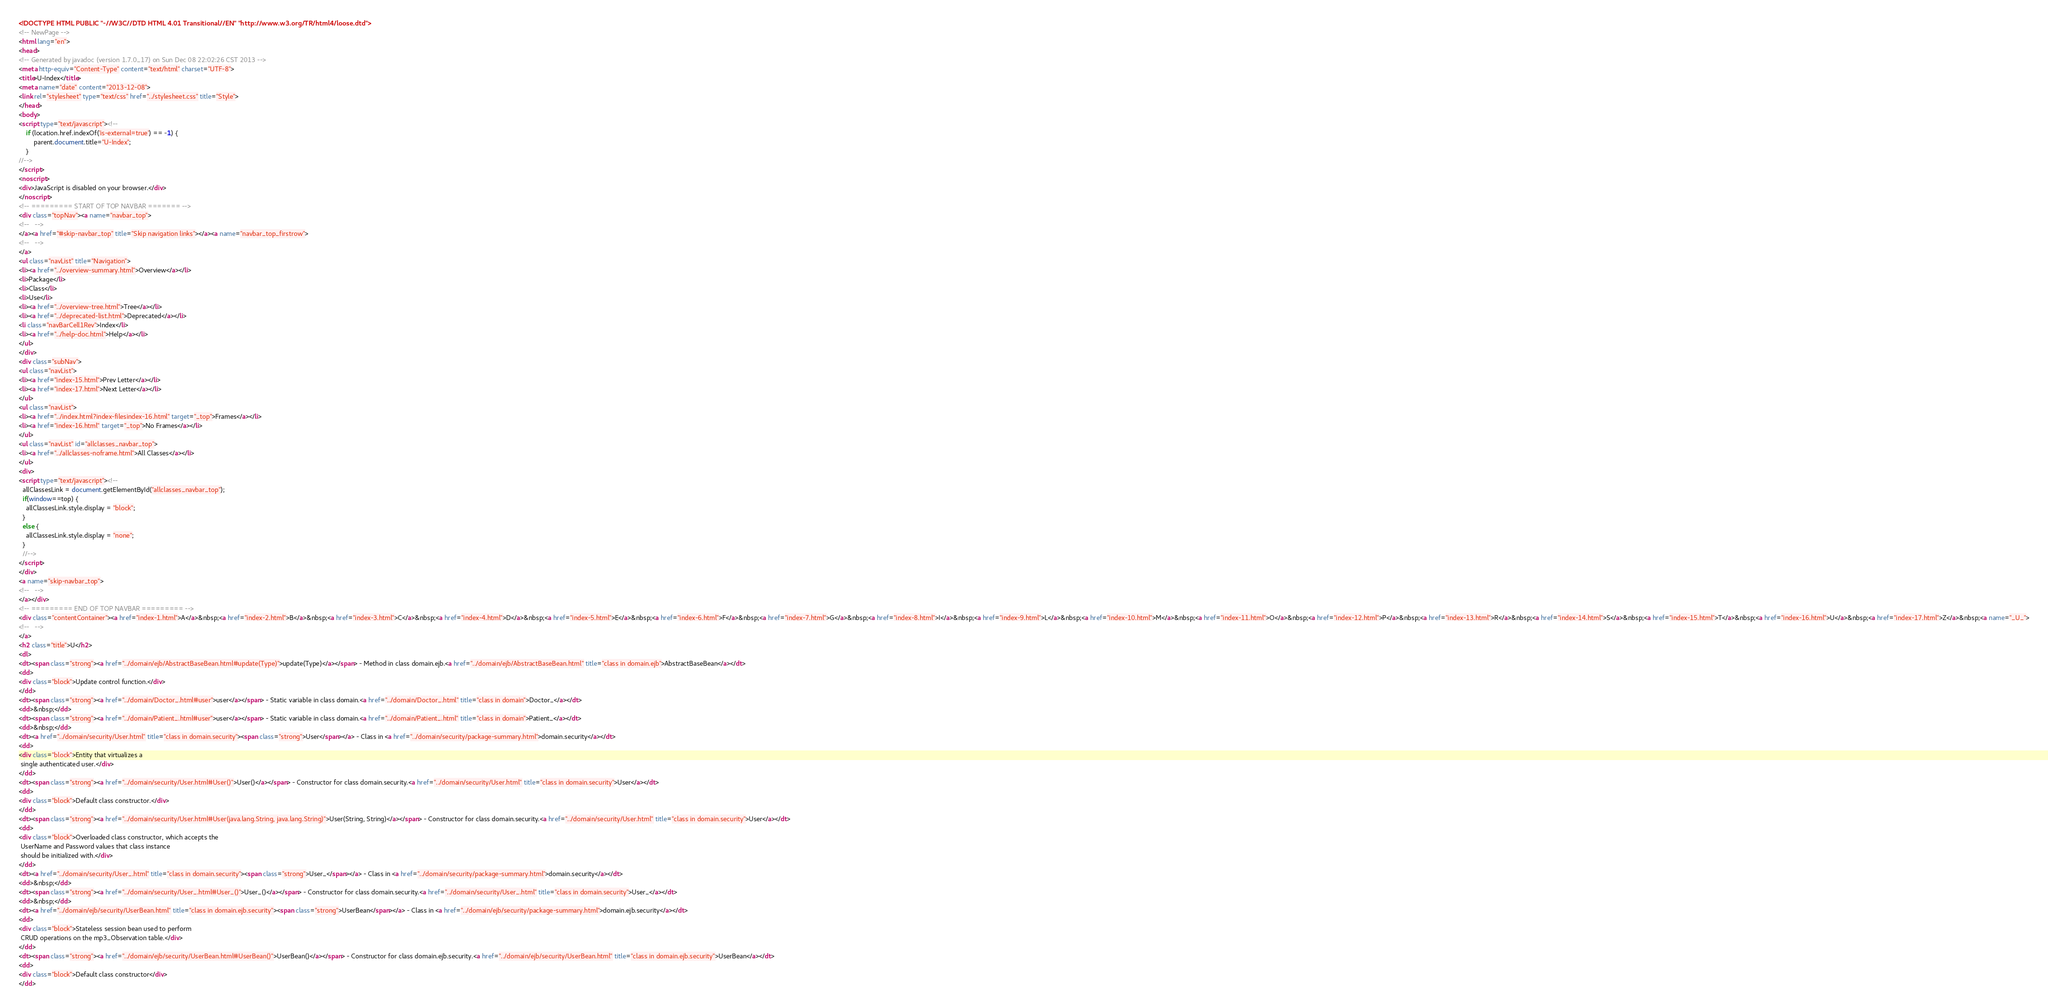Convert code to text. <code><loc_0><loc_0><loc_500><loc_500><_HTML_><!DOCTYPE HTML PUBLIC "-//W3C//DTD HTML 4.01 Transitional//EN" "http://www.w3.org/TR/html4/loose.dtd">
<!-- NewPage -->
<html lang="en">
<head>
<!-- Generated by javadoc (version 1.7.0_17) on Sun Dec 08 22:02:26 CST 2013 -->
<meta http-equiv="Content-Type" content="text/html" charset="UTF-8">
<title>U-Index</title>
<meta name="date" content="2013-12-08">
<link rel="stylesheet" type="text/css" href="../stylesheet.css" title="Style">
</head>
<body>
<script type="text/javascript"><!--
    if (location.href.indexOf('is-external=true') == -1) {
        parent.document.title="U-Index";
    }
//-->
</script>
<noscript>
<div>JavaScript is disabled on your browser.</div>
</noscript>
<!-- ========= START OF TOP NAVBAR ======= -->
<div class="topNav"><a name="navbar_top">
<!--   -->
</a><a href="#skip-navbar_top" title="Skip navigation links"></a><a name="navbar_top_firstrow">
<!--   -->
</a>
<ul class="navList" title="Navigation">
<li><a href="../overview-summary.html">Overview</a></li>
<li>Package</li>
<li>Class</li>
<li>Use</li>
<li><a href="../overview-tree.html">Tree</a></li>
<li><a href="../deprecated-list.html">Deprecated</a></li>
<li class="navBarCell1Rev">Index</li>
<li><a href="../help-doc.html">Help</a></li>
</ul>
</div>
<div class="subNav">
<ul class="navList">
<li><a href="index-15.html">Prev Letter</a></li>
<li><a href="index-17.html">Next Letter</a></li>
</ul>
<ul class="navList">
<li><a href="../index.html?index-filesindex-16.html" target="_top">Frames</a></li>
<li><a href="index-16.html" target="_top">No Frames</a></li>
</ul>
<ul class="navList" id="allclasses_navbar_top">
<li><a href="../allclasses-noframe.html">All Classes</a></li>
</ul>
<div>
<script type="text/javascript"><!--
  allClassesLink = document.getElementById("allclasses_navbar_top");
  if(window==top) {
    allClassesLink.style.display = "block";
  }
  else {
    allClassesLink.style.display = "none";
  }
  //-->
</script>
</div>
<a name="skip-navbar_top">
<!--   -->
</a></div>
<!-- ========= END OF TOP NAVBAR ========= -->
<div class="contentContainer"><a href="index-1.html">A</a>&nbsp;<a href="index-2.html">B</a>&nbsp;<a href="index-3.html">C</a>&nbsp;<a href="index-4.html">D</a>&nbsp;<a href="index-5.html">E</a>&nbsp;<a href="index-6.html">F</a>&nbsp;<a href="index-7.html">G</a>&nbsp;<a href="index-8.html">I</a>&nbsp;<a href="index-9.html">L</a>&nbsp;<a href="index-10.html">M</a>&nbsp;<a href="index-11.html">O</a>&nbsp;<a href="index-12.html">P</a>&nbsp;<a href="index-13.html">R</a>&nbsp;<a href="index-14.html">S</a>&nbsp;<a href="index-15.html">T</a>&nbsp;<a href="index-16.html">U</a>&nbsp;<a href="index-17.html">Z</a>&nbsp;<a name="_U_">
<!--   -->
</a>
<h2 class="title">U</h2>
<dl>
<dt><span class="strong"><a href="../domain/ejb/AbstractBaseBean.html#update(Type)">update(Type)</a></span> - Method in class domain.ejb.<a href="../domain/ejb/AbstractBaseBean.html" title="class in domain.ejb">AbstractBaseBean</a></dt>
<dd>
<div class="block">Update control function.</div>
</dd>
<dt><span class="strong"><a href="../domain/Doctor_.html#user">user</a></span> - Static variable in class domain.<a href="../domain/Doctor_.html" title="class in domain">Doctor_</a></dt>
<dd>&nbsp;</dd>
<dt><span class="strong"><a href="../domain/Patient_.html#user">user</a></span> - Static variable in class domain.<a href="../domain/Patient_.html" title="class in domain">Patient_</a></dt>
<dd>&nbsp;</dd>
<dt><a href="../domain/security/User.html" title="class in domain.security"><span class="strong">User</span></a> - Class in <a href="../domain/security/package-summary.html">domain.security</a></dt>
<dd>
<div class="block">Entity that virtualizes a 
 single authenticated user.</div>
</dd>
<dt><span class="strong"><a href="../domain/security/User.html#User()">User()</a></span> - Constructor for class domain.security.<a href="../domain/security/User.html" title="class in domain.security">User</a></dt>
<dd>
<div class="block">Default class constructor.</div>
</dd>
<dt><span class="strong"><a href="../domain/security/User.html#User(java.lang.String, java.lang.String)">User(String, String)</a></span> - Constructor for class domain.security.<a href="../domain/security/User.html" title="class in domain.security">User</a></dt>
<dd>
<div class="block">Overloaded class constructor, which accepts the
 UserName and Password values that class instance
 should be initialized with.</div>
</dd>
<dt><a href="../domain/security/User_.html" title="class in domain.security"><span class="strong">User_</span></a> - Class in <a href="../domain/security/package-summary.html">domain.security</a></dt>
<dd>&nbsp;</dd>
<dt><span class="strong"><a href="../domain/security/User_.html#User_()">User_()</a></span> - Constructor for class domain.security.<a href="../domain/security/User_.html" title="class in domain.security">User_</a></dt>
<dd>&nbsp;</dd>
<dt><a href="../domain/ejb/security/UserBean.html" title="class in domain.ejb.security"><span class="strong">UserBean</span></a> - Class in <a href="../domain/ejb/security/package-summary.html">domain.ejb.security</a></dt>
<dd>
<div class="block">Stateless session bean used to perform
 CRUD operations on the mp3_Observation table.</div>
</dd>
<dt><span class="strong"><a href="../domain/ejb/security/UserBean.html#UserBean()">UserBean()</a></span> - Constructor for class domain.ejb.security.<a href="../domain/ejb/security/UserBean.html" title="class in domain.ejb.security">UserBean</a></dt>
<dd>
<div class="block">Default class constructor</div>
</dd></code> 